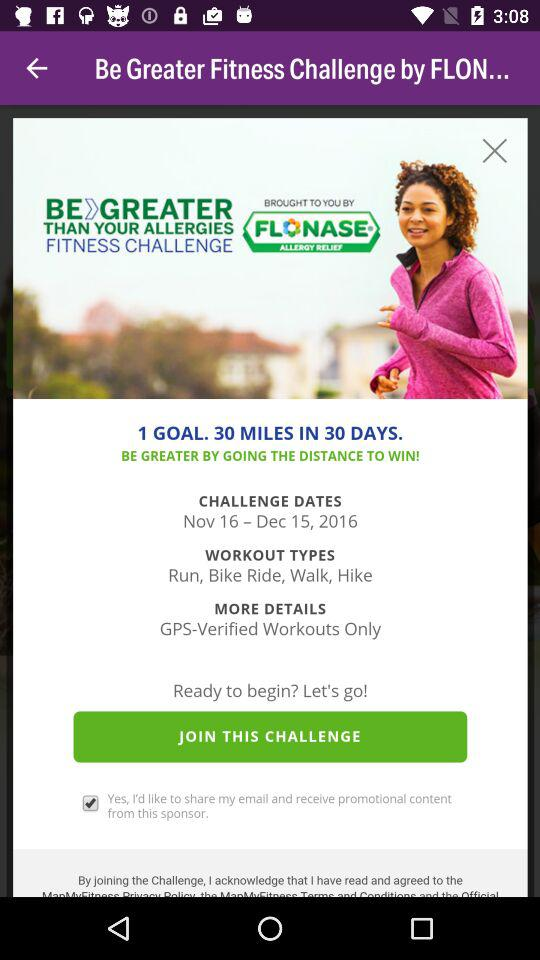What are the challenge dates? The challenge dates are from November 16, 2016 to December 15, 2016. 